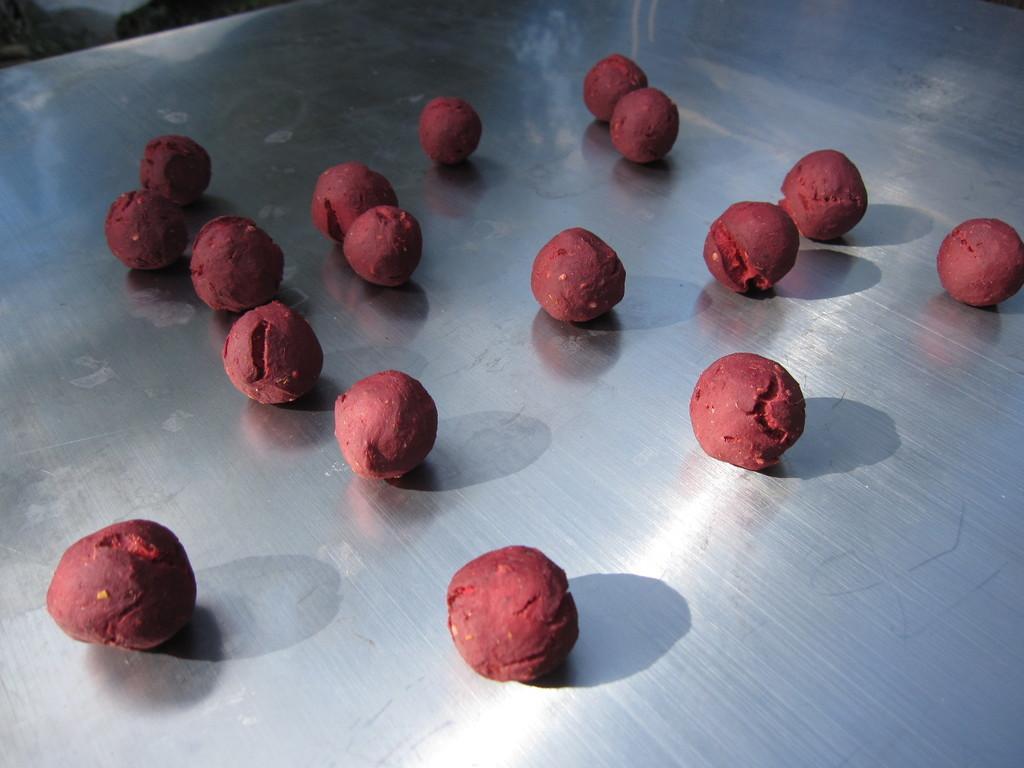Describe this image in one or two sentences. In this image I can see the silver colored surface and on the silver colored surface I can see few balls which are red in color. 